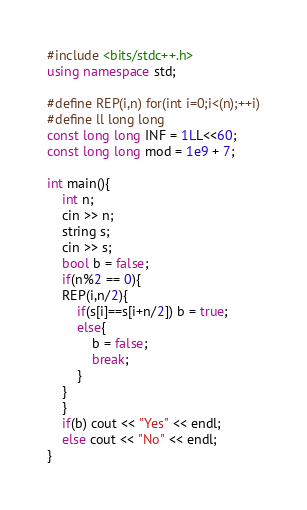<code> <loc_0><loc_0><loc_500><loc_500><_C++_>#include <bits/stdc++.h>
using namespace std;
 
#define REP(i,n) for(int i=0;i<(n);++i)
#define ll long long
const long long INF = 1LL<<60;
const long long mod = 1e9 + 7;
 
int main(){
    int n;
    cin >> n;
    string s;
    cin >> s;
    bool b = false;
    if(n%2 == 0){
    REP(i,n/2){
        if(s[i]==s[i+n/2]) b = true;
        else{
            b = false;
            break;
        }
    }
    }
    if(b) cout << "Yes" << endl;
    else cout << "No" << endl;
}</code> 